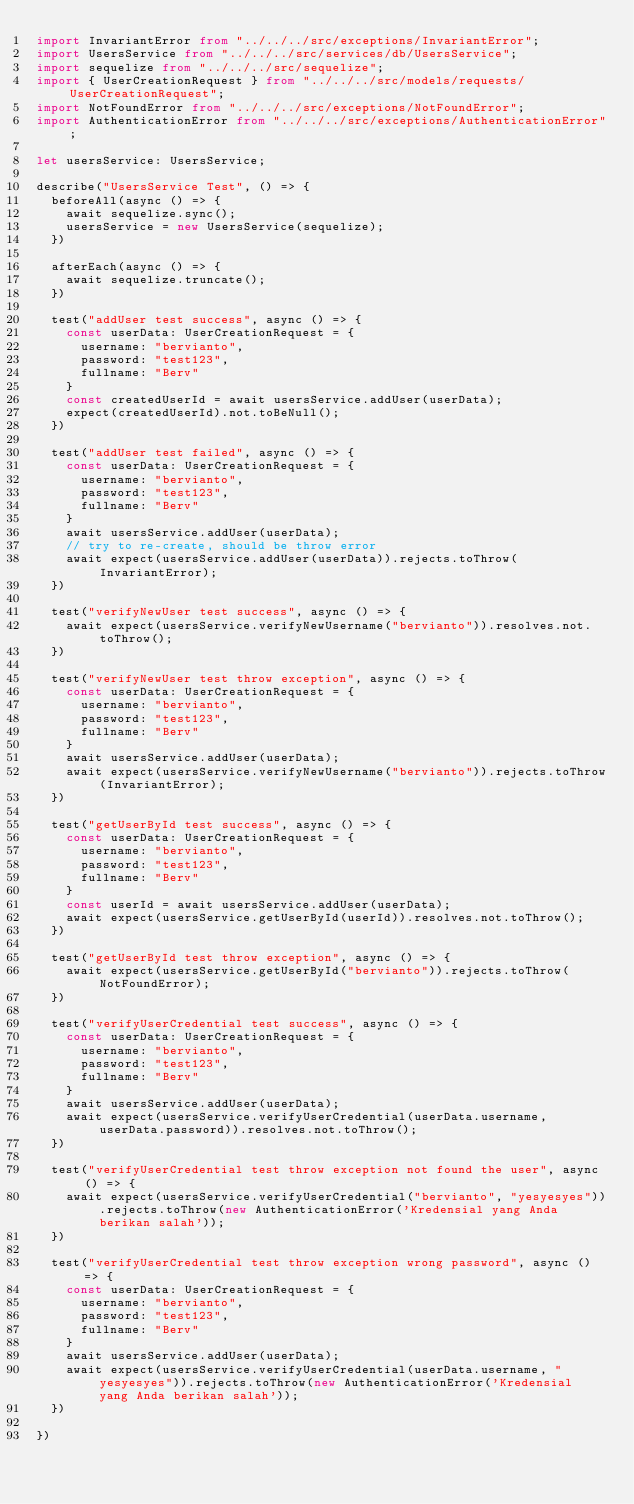<code> <loc_0><loc_0><loc_500><loc_500><_TypeScript_>import InvariantError from "../../../src/exceptions/InvariantError";
import UsersService from "../../../src/services/db/UsersService";
import sequelize from "../../../src/sequelize";
import { UserCreationRequest } from "../../../src/models/requests/UserCreationRequest";
import NotFoundError from "../../../src/exceptions/NotFoundError";
import AuthenticationError from "../../../src/exceptions/AuthenticationError";

let usersService: UsersService;

describe("UsersService Test", () => {
  beforeAll(async () => {
    await sequelize.sync();
    usersService = new UsersService(sequelize);
  })

  afterEach(async () => {
    await sequelize.truncate();
  })

  test("addUser test success", async () => {
    const userData: UserCreationRequest = {
      username: "bervianto",
      password: "test123",
      fullname: "Berv"
    }
    const createdUserId = await usersService.addUser(userData);
    expect(createdUserId).not.toBeNull();
  })

  test("addUser test failed", async () => {
    const userData: UserCreationRequest = {
      username: "bervianto",
      password: "test123",
      fullname: "Berv"
    }
    await usersService.addUser(userData);
    // try to re-create, should be throw error
    await expect(usersService.addUser(userData)).rejects.toThrow(InvariantError);
  })

  test("verifyNewUser test success", async () => {
    await expect(usersService.verifyNewUsername("bervianto")).resolves.not.toThrow();
  })

  test("verifyNewUser test throw exception", async () => {
    const userData: UserCreationRequest = {
      username: "bervianto",
      password: "test123",
      fullname: "Berv"
    }
    await usersService.addUser(userData);
    await expect(usersService.verifyNewUsername("bervianto")).rejects.toThrow(InvariantError);
  })

  test("getUserById test success", async () => {
    const userData: UserCreationRequest = {
      username: "bervianto",
      password: "test123",
      fullname: "Berv"
    }
    const userId = await usersService.addUser(userData);
    await expect(usersService.getUserById(userId)).resolves.not.toThrow();
  })

  test("getUserById test throw exception", async () => {
    await expect(usersService.getUserById("bervianto")).rejects.toThrow(NotFoundError);
  })

  test("verifyUserCredential test success", async () => {
    const userData: UserCreationRequest = {
      username: "bervianto",
      password: "test123",
      fullname: "Berv"
    }
    await usersService.addUser(userData);
    await expect(usersService.verifyUserCredential(userData.username, userData.password)).resolves.not.toThrow();
  })

  test("verifyUserCredential test throw exception not found the user", async () => {
    await expect(usersService.verifyUserCredential("bervianto", "yesyesyes")).rejects.toThrow(new AuthenticationError('Kredensial yang Anda berikan salah'));
  })

  test("verifyUserCredential test throw exception wrong password", async () => {
    const userData: UserCreationRequest = {
      username: "bervianto",
      password: "test123",
      fullname: "Berv"
    }
    await usersService.addUser(userData);
    await expect(usersService.verifyUserCredential(userData.username, "yesyesyes")).rejects.toThrow(new AuthenticationError('Kredensial yang Anda berikan salah'));
  })

})</code> 